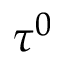Convert formula to latex. <formula><loc_0><loc_0><loc_500><loc_500>\tau ^ { 0 }</formula> 